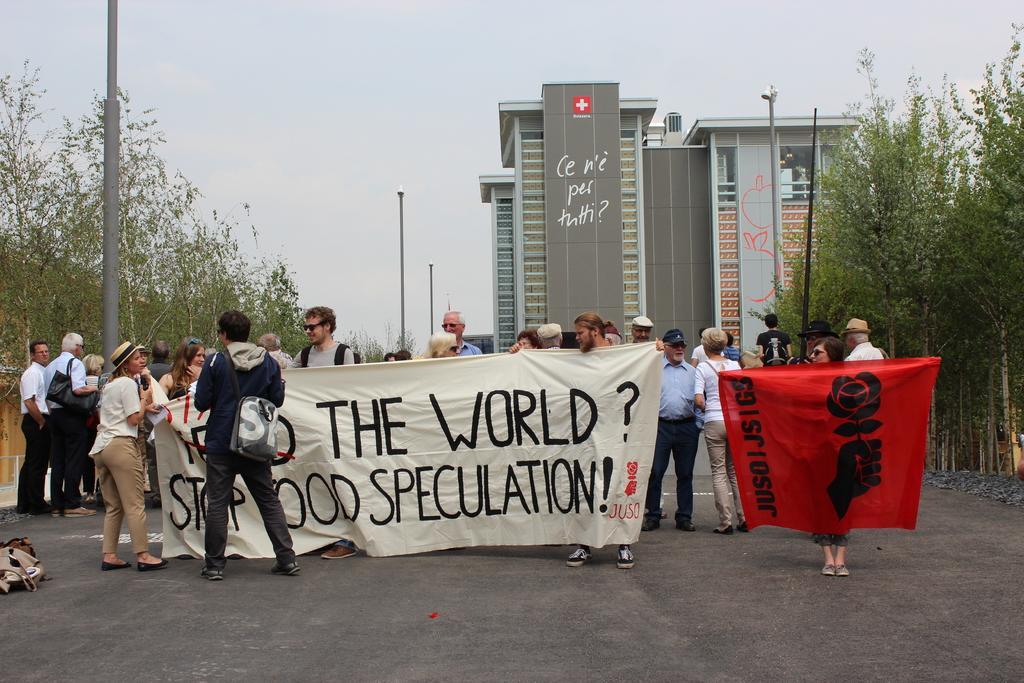In one or two sentences, can you explain what this image depicts? In this image, there are a few people, poles, trees, banners with text and images. We can see a building and the ground with some objects. We can see the sky. 